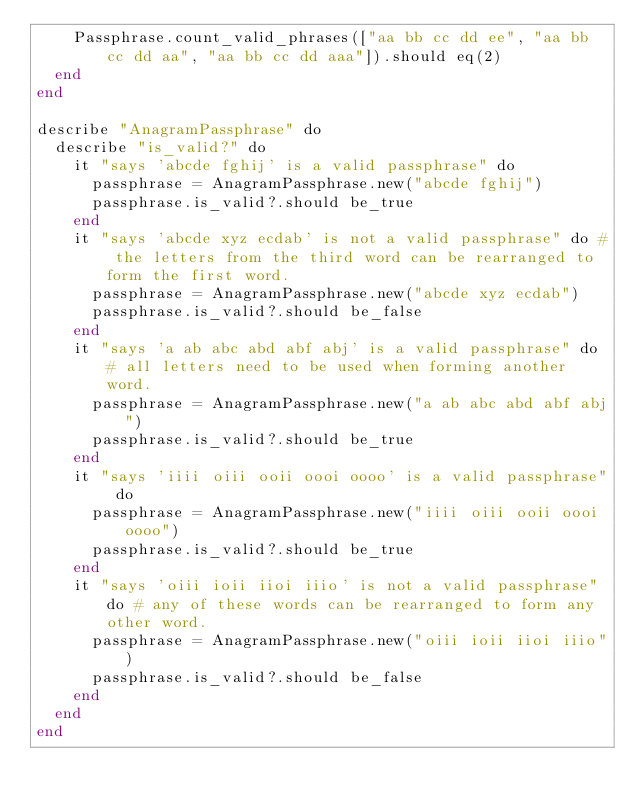Convert code to text. <code><loc_0><loc_0><loc_500><loc_500><_Crystal_>    Passphrase.count_valid_phrases(["aa bb cc dd ee", "aa bb cc dd aa", "aa bb cc dd aaa"]).should eq(2)
  end
end

describe "AnagramPassphrase" do
  describe "is_valid?" do
    it "says 'abcde fghij' is a valid passphrase" do
      passphrase = AnagramPassphrase.new("abcde fghij")
      passphrase.is_valid?.should be_true
    end
    it "says 'abcde xyz ecdab' is not a valid passphrase" do # the letters from the third word can be rearranged to form the first word.
      passphrase = AnagramPassphrase.new("abcde xyz ecdab")
      passphrase.is_valid?.should be_false
    end
    it "says 'a ab abc abd abf abj' is a valid passphrase" do # all letters need to be used when forming another word.
      passphrase = AnagramPassphrase.new("a ab abc abd abf abj")
      passphrase.is_valid?.should be_true
    end
    it "says 'iiii oiii ooii oooi oooo' is a valid passphrase" do
      passphrase = AnagramPassphrase.new("iiii oiii ooii oooi oooo")
      passphrase.is_valid?.should be_true
    end
    it "says 'oiii ioii iioi iiio' is not a valid passphrase" do # any of these words can be rearranged to form any other word.
      passphrase = AnagramPassphrase.new("oiii ioii iioi iiio")
      passphrase.is_valid?.should be_false
    end
  end
end
</code> 